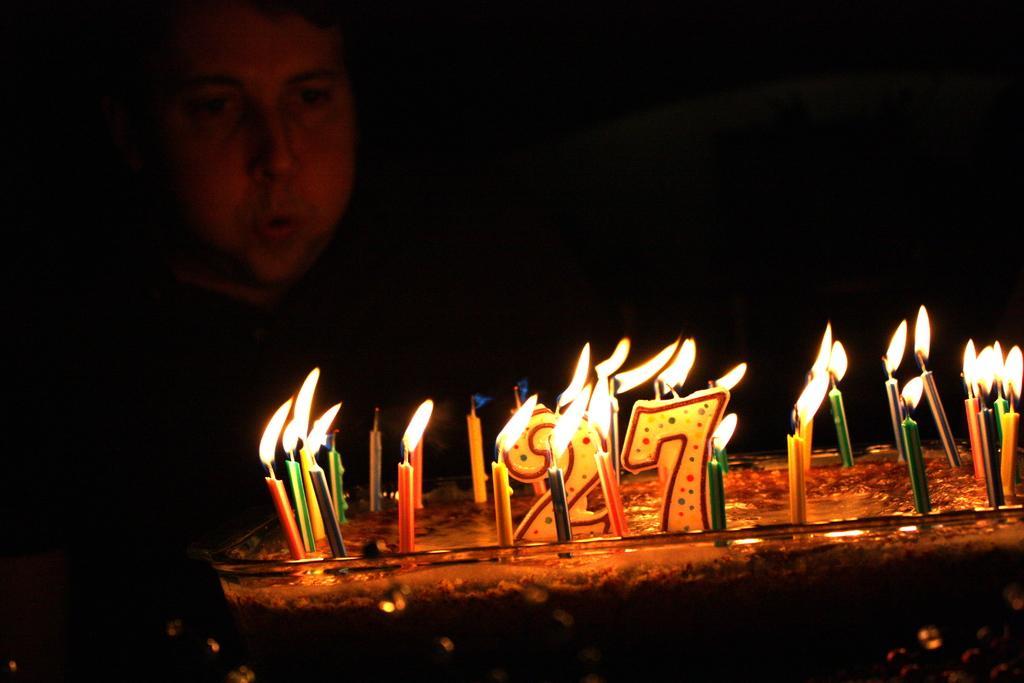How would you summarize this image in a sentence or two? In this picture I see a cake in front on which there are many candles. In the background I see a man and I see that it is totally dark. 